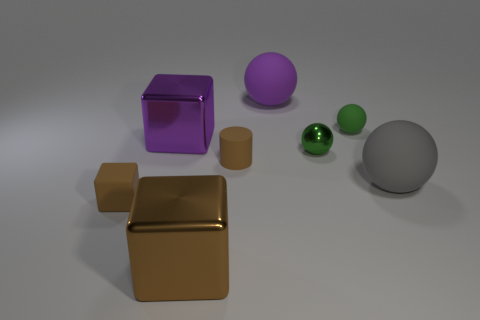There is another small green thing that is the same shape as the small metal thing; what material is it?
Your response must be concise. Rubber. There is a big purple thing that is in front of the large object that is behind the purple metal object; is there a green ball that is left of it?
Keep it short and to the point. No. Does the brown rubber thing behind the brown matte cube have the same shape as the small brown rubber thing that is left of the cylinder?
Your answer should be compact. No. Is the number of small objects that are behind the gray ball greater than the number of metallic objects?
Offer a very short reply. No. How many things are either green shiny spheres or brown matte cubes?
Provide a short and direct response. 2. What is the color of the rubber block?
Give a very brief answer. Brown. What number of other objects are there of the same color as the small shiny object?
Offer a very short reply. 1. There is a tiny matte block; are there any big rubber balls to the left of it?
Provide a short and direct response. No. What color is the large object left of the large metal object in front of the big shiny object behind the large brown cube?
Your answer should be compact. Purple. What number of brown rubber objects are both to the right of the brown metallic block and to the left of the big brown block?
Your answer should be compact. 0. 